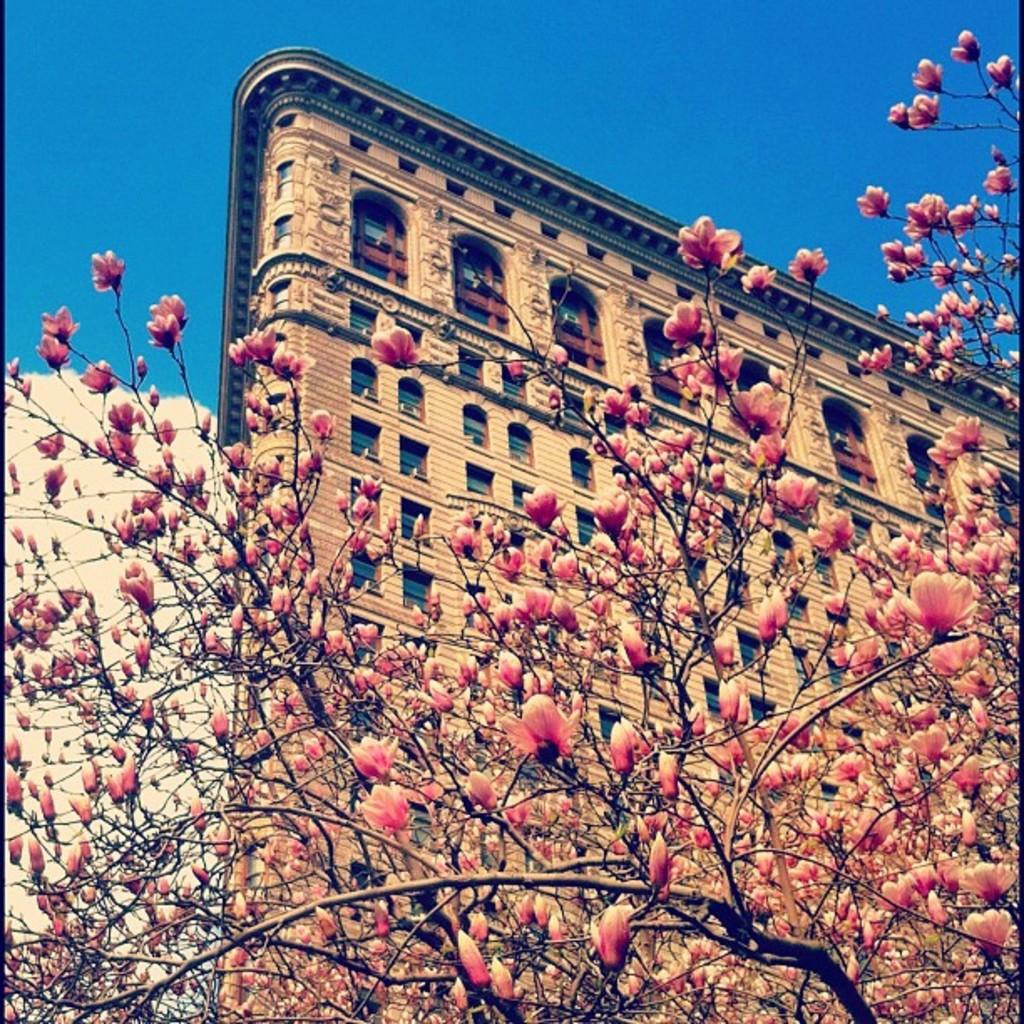What is the main object in the foreground of the image? There is a tree in the foreground of the image. What can be seen in the background of the image? There is a building and the sky visible in the background of the image. What is the reaction of the tree to the number of clouds in the sky? There is no reaction of the tree to the number of clouds in the sky, as trees do not have the ability to react to such stimuli. 